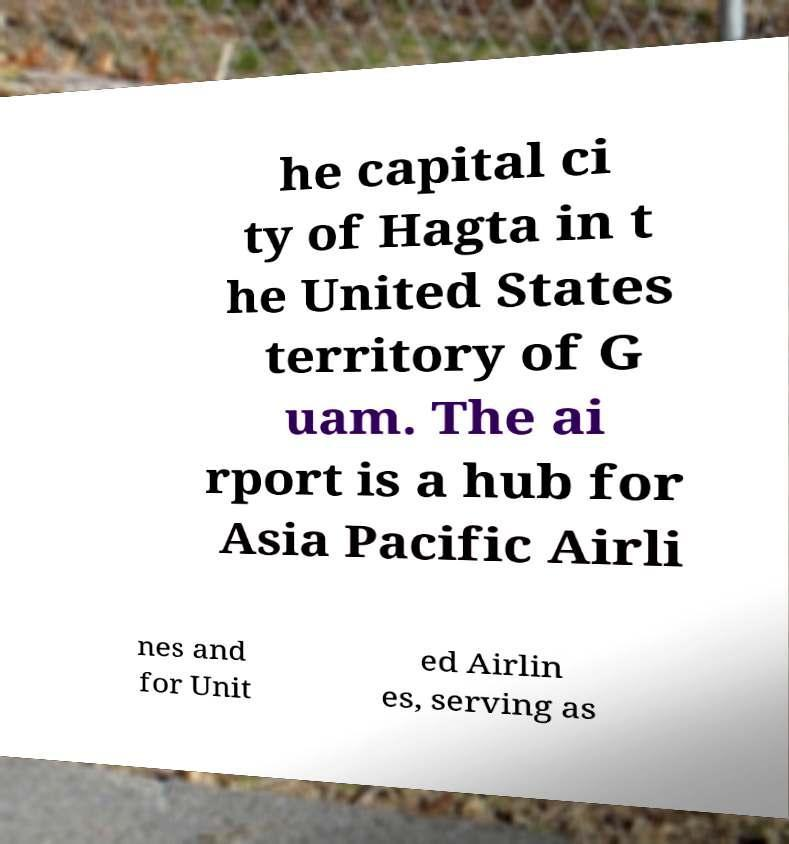There's text embedded in this image that I need extracted. Can you transcribe it verbatim? he capital ci ty of Hagta in t he United States territory of G uam. The ai rport is a hub for Asia Pacific Airli nes and for Unit ed Airlin es, serving as 